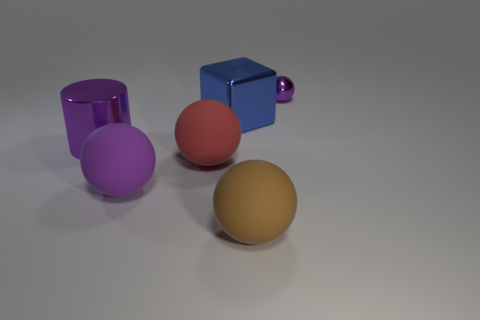Subtract all large balls. How many balls are left? 1 Subtract all red blocks. How many purple balls are left? 2 Add 1 small yellow things. How many objects exist? 7 Subtract all red spheres. How many spheres are left? 3 Subtract 2 balls. How many balls are left? 2 Subtract all spheres. How many objects are left? 2 Subtract 0 cyan blocks. How many objects are left? 6 Subtract all green balls. Subtract all blue cylinders. How many balls are left? 4 Subtract all big gray cylinders. Subtract all small purple shiny spheres. How many objects are left? 5 Add 2 rubber objects. How many rubber objects are left? 5 